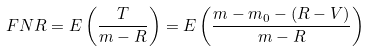<formula> <loc_0><loc_0><loc_500><loc_500>F N R = E \left ( { \frac { T } { m - R } } \right ) = E \left ( { \frac { m - m _ { 0 } - ( R - V ) } { m - R } } \right )</formula> 